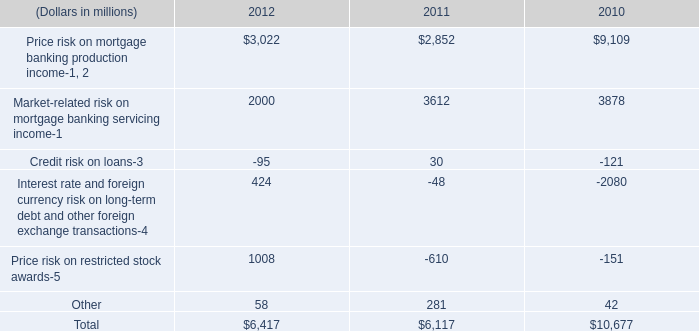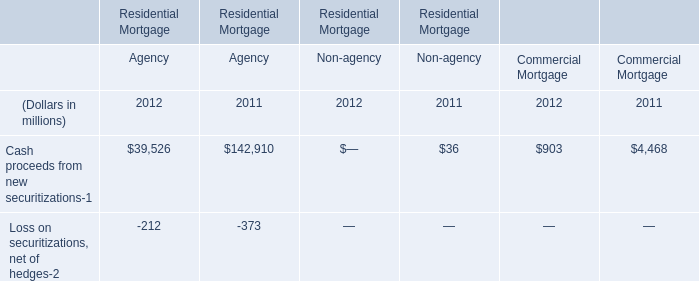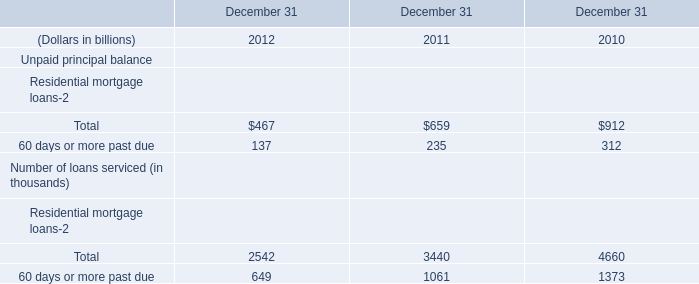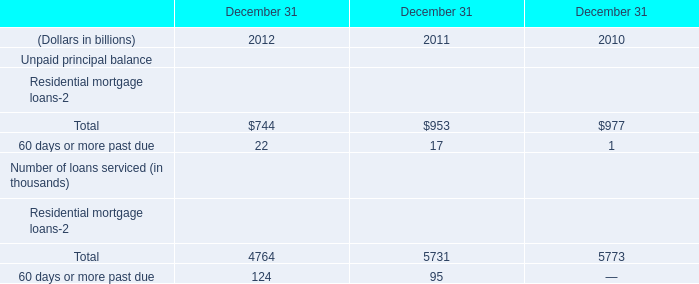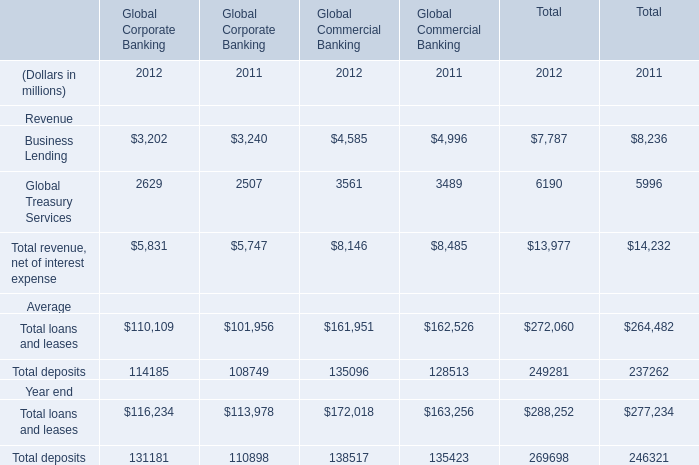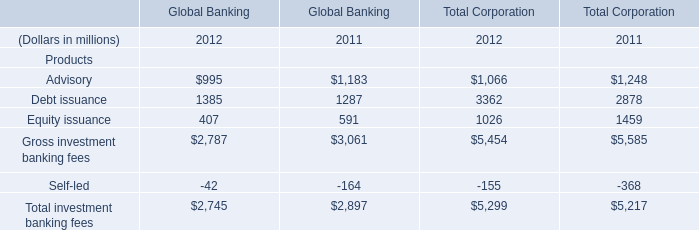If Global Treasury Services of Global Commercial Banking develops with the same increasing rate in 2012, what will it reach in 2013? (in millions) 
Computations: ((1 + ((3561 - 3489) / 3489)) * 3561)
Answer: 3634.48581. 